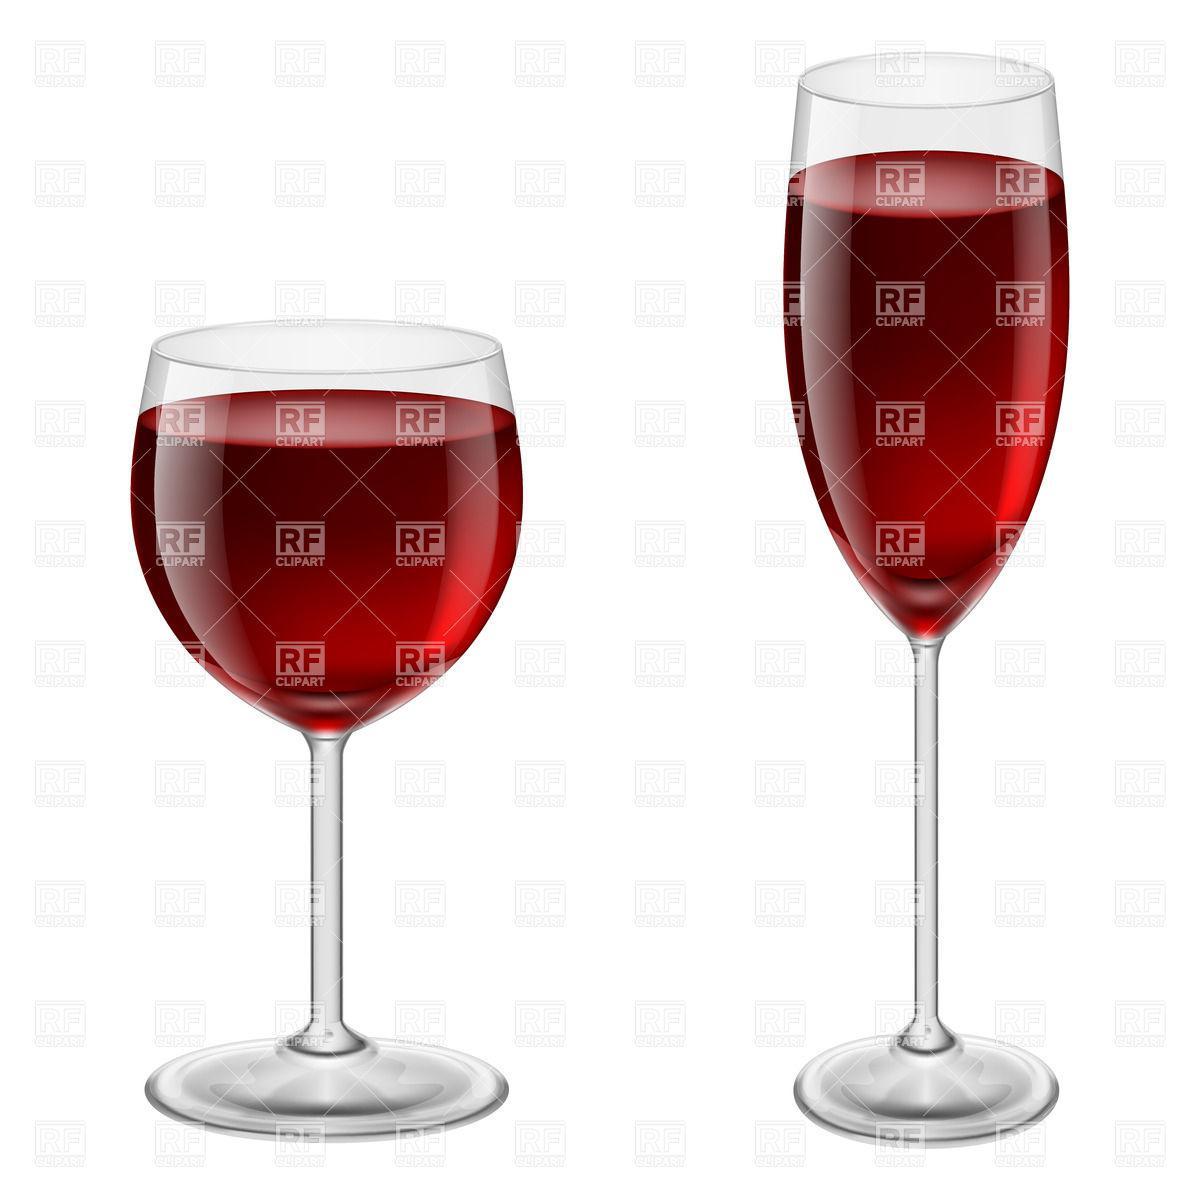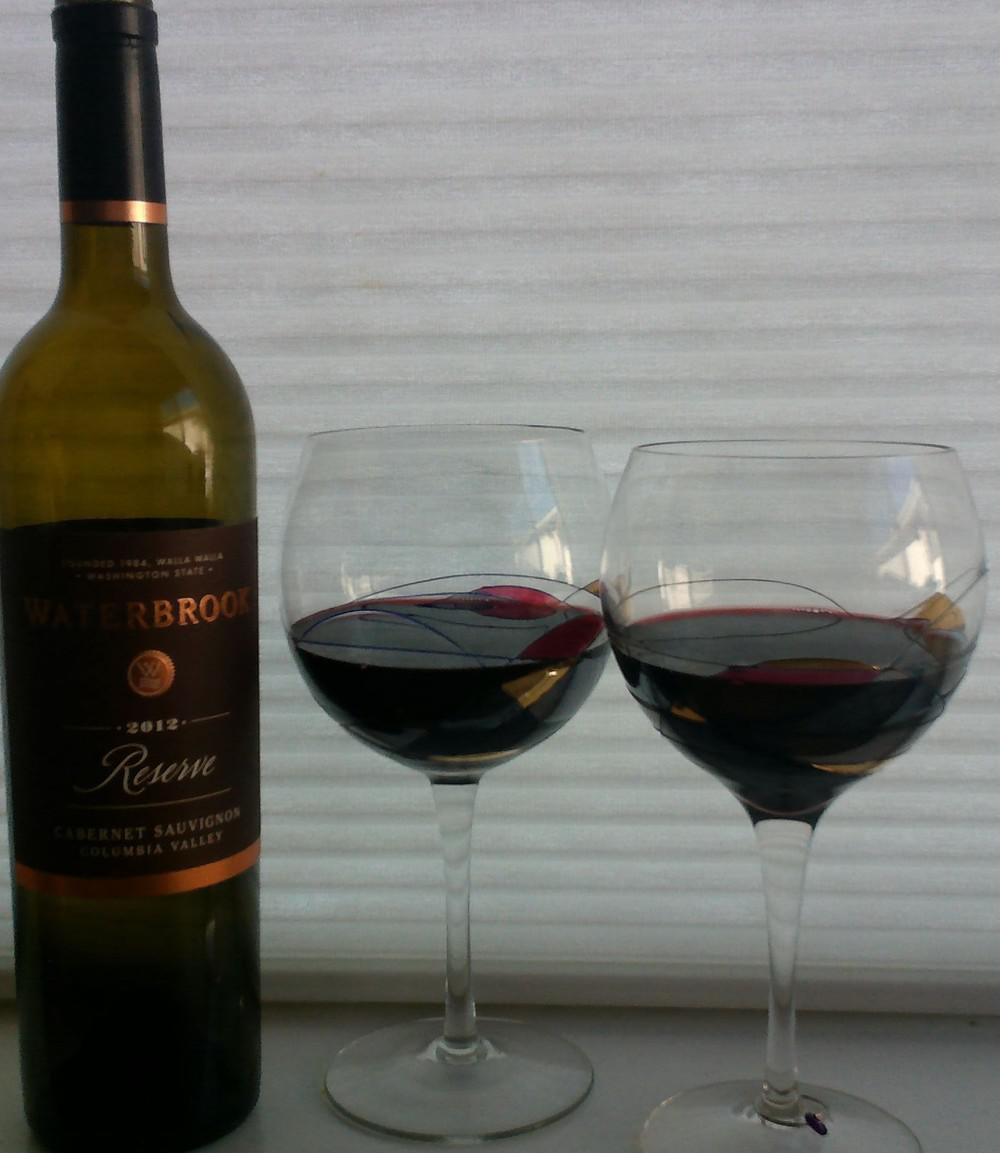The first image is the image on the left, the second image is the image on the right. Examine the images to the left and right. Is the description "An image depicts red wine splashing in a stemmed glass." accurate? Answer yes or no. No. The first image is the image on the left, the second image is the image on the right. Assess this claim about the two images: "A bottle of wine is near at least one wine glass in one of the images.". Correct or not? Answer yes or no. Yes. 